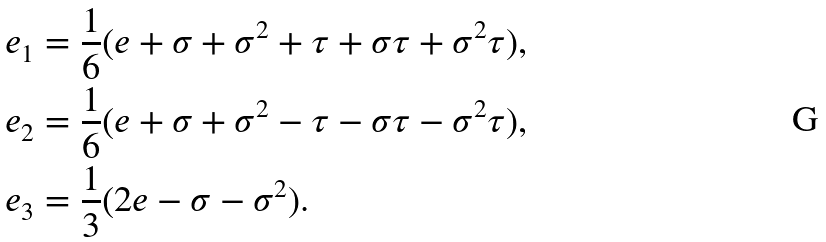<formula> <loc_0><loc_0><loc_500><loc_500>e _ { 1 } & = \frac { 1 } { 6 } ( e + \sigma + \sigma ^ { 2 } + \tau + \sigma \tau + \sigma ^ { 2 } \tau ) , \\ e _ { 2 } & = \frac { 1 } { 6 } ( e + \sigma + \sigma ^ { 2 } - \tau - \sigma \tau - \sigma ^ { 2 } \tau ) , \\ e _ { 3 } & = \frac { 1 } { 3 } ( 2 e - \sigma - \sigma ^ { 2 } ) .</formula> 